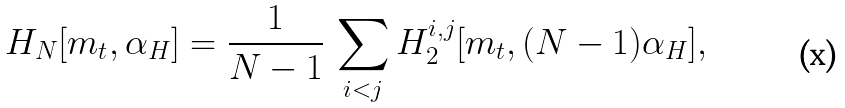Convert formula to latex. <formula><loc_0><loc_0><loc_500><loc_500>H _ { N } [ m _ { t } , \alpha _ { H } ] = \frac { 1 } { N - 1 } \, \sum _ { i < j } H _ { 2 } ^ { i , j } [ m _ { t } , ( N - 1 ) \alpha _ { H } ] ,</formula> 